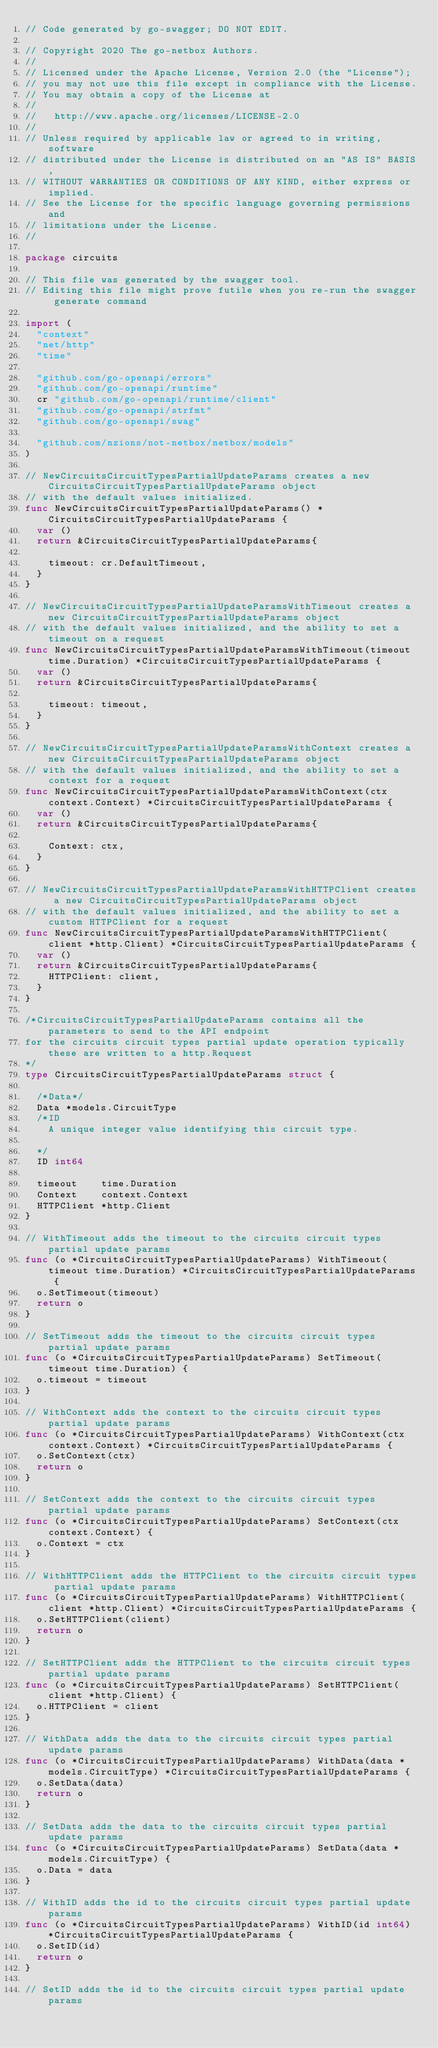Convert code to text. <code><loc_0><loc_0><loc_500><loc_500><_Go_>// Code generated by go-swagger; DO NOT EDIT.

// Copyright 2020 The go-netbox Authors.
//
// Licensed under the Apache License, Version 2.0 (the "License");
// you may not use this file except in compliance with the License.
// You may obtain a copy of the License at
//
//   http://www.apache.org/licenses/LICENSE-2.0
//
// Unless required by applicable law or agreed to in writing, software
// distributed under the License is distributed on an "AS IS" BASIS,
// WITHOUT WARRANTIES OR CONDITIONS OF ANY KIND, either express or implied.
// See the License for the specific language governing permissions and
// limitations under the License.
//

package circuits

// This file was generated by the swagger tool.
// Editing this file might prove futile when you re-run the swagger generate command

import (
	"context"
	"net/http"
	"time"

	"github.com/go-openapi/errors"
	"github.com/go-openapi/runtime"
	cr "github.com/go-openapi/runtime/client"
	"github.com/go-openapi/strfmt"
	"github.com/go-openapi/swag"

	"github.com/nzions/not-netbox/netbox/models"
)

// NewCircuitsCircuitTypesPartialUpdateParams creates a new CircuitsCircuitTypesPartialUpdateParams object
// with the default values initialized.
func NewCircuitsCircuitTypesPartialUpdateParams() *CircuitsCircuitTypesPartialUpdateParams {
	var ()
	return &CircuitsCircuitTypesPartialUpdateParams{

		timeout: cr.DefaultTimeout,
	}
}

// NewCircuitsCircuitTypesPartialUpdateParamsWithTimeout creates a new CircuitsCircuitTypesPartialUpdateParams object
// with the default values initialized, and the ability to set a timeout on a request
func NewCircuitsCircuitTypesPartialUpdateParamsWithTimeout(timeout time.Duration) *CircuitsCircuitTypesPartialUpdateParams {
	var ()
	return &CircuitsCircuitTypesPartialUpdateParams{

		timeout: timeout,
	}
}

// NewCircuitsCircuitTypesPartialUpdateParamsWithContext creates a new CircuitsCircuitTypesPartialUpdateParams object
// with the default values initialized, and the ability to set a context for a request
func NewCircuitsCircuitTypesPartialUpdateParamsWithContext(ctx context.Context) *CircuitsCircuitTypesPartialUpdateParams {
	var ()
	return &CircuitsCircuitTypesPartialUpdateParams{

		Context: ctx,
	}
}

// NewCircuitsCircuitTypesPartialUpdateParamsWithHTTPClient creates a new CircuitsCircuitTypesPartialUpdateParams object
// with the default values initialized, and the ability to set a custom HTTPClient for a request
func NewCircuitsCircuitTypesPartialUpdateParamsWithHTTPClient(client *http.Client) *CircuitsCircuitTypesPartialUpdateParams {
	var ()
	return &CircuitsCircuitTypesPartialUpdateParams{
		HTTPClient: client,
	}
}

/*CircuitsCircuitTypesPartialUpdateParams contains all the parameters to send to the API endpoint
for the circuits circuit types partial update operation typically these are written to a http.Request
*/
type CircuitsCircuitTypesPartialUpdateParams struct {

	/*Data*/
	Data *models.CircuitType
	/*ID
	  A unique integer value identifying this circuit type.

	*/
	ID int64

	timeout    time.Duration
	Context    context.Context
	HTTPClient *http.Client
}

// WithTimeout adds the timeout to the circuits circuit types partial update params
func (o *CircuitsCircuitTypesPartialUpdateParams) WithTimeout(timeout time.Duration) *CircuitsCircuitTypesPartialUpdateParams {
	o.SetTimeout(timeout)
	return o
}

// SetTimeout adds the timeout to the circuits circuit types partial update params
func (o *CircuitsCircuitTypesPartialUpdateParams) SetTimeout(timeout time.Duration) {
	o.timeout = timeout
}

// WithContext adds the context to the circuits circuit types partial update params
func (o *CircuitsCircuitTypesPartialUpdateParams) WithContext(ctx context.Context) *CircuitsCircuitTypesPartialUpdateParams {
	o.SetContext(ctx)
	return o
}

// SetContext adds the context to the circuits circuit types partial update params
func (o *CircuitsCircuitTypesPartialUpdateParams) SetContext(ctx context.Context) {
	o.Context = ctx
}

// WithHTTPClient adds the HTTPClient to the circuits circuit types partial update params
func (o *CircuitsCircuitTypesPartialUpdateParams) WithHTTPClient(client *http.Client) *CircuitsCircuitTypesPartialUpdateParams {
	o.SetHTTPClient(client)
	return o
}

// SetHTTPClient adds the HTTPClient to the circuits circuit types partial update params
func (o *CircuitsCircuitTypesPartialUpdateParams) SetHTTPClient(client *http.Client) {
	o.HTTPClient = client
}

// WithData adds the data to the circuits circuit types partial update params
func (o *CircuitsCircuitTypesPartialUpdateParams) WithData(data *models.CircuitType) *CircuitsCircuitTypesPartialUpdateParams {
	o.SetData(data)
	return o
}

// SetData adds the data to the circuits circuit types partial update params
func (o *CircuitsCircuitTypesPartialUpdateParams) SetData(data *models.CircuitType) {
	o.Data = data
}

// WithID adds the id to the circuits circuit types partial update params
func (o *CircuitsCircuitTypesPartialUpdateParams) WithID(id int64) *CircuitsCircuitTypesPartialUpdateParams {
	o.SetID(id)
	return o
}

// SetID adds the id to the circuits circuit types partial update params</code> 